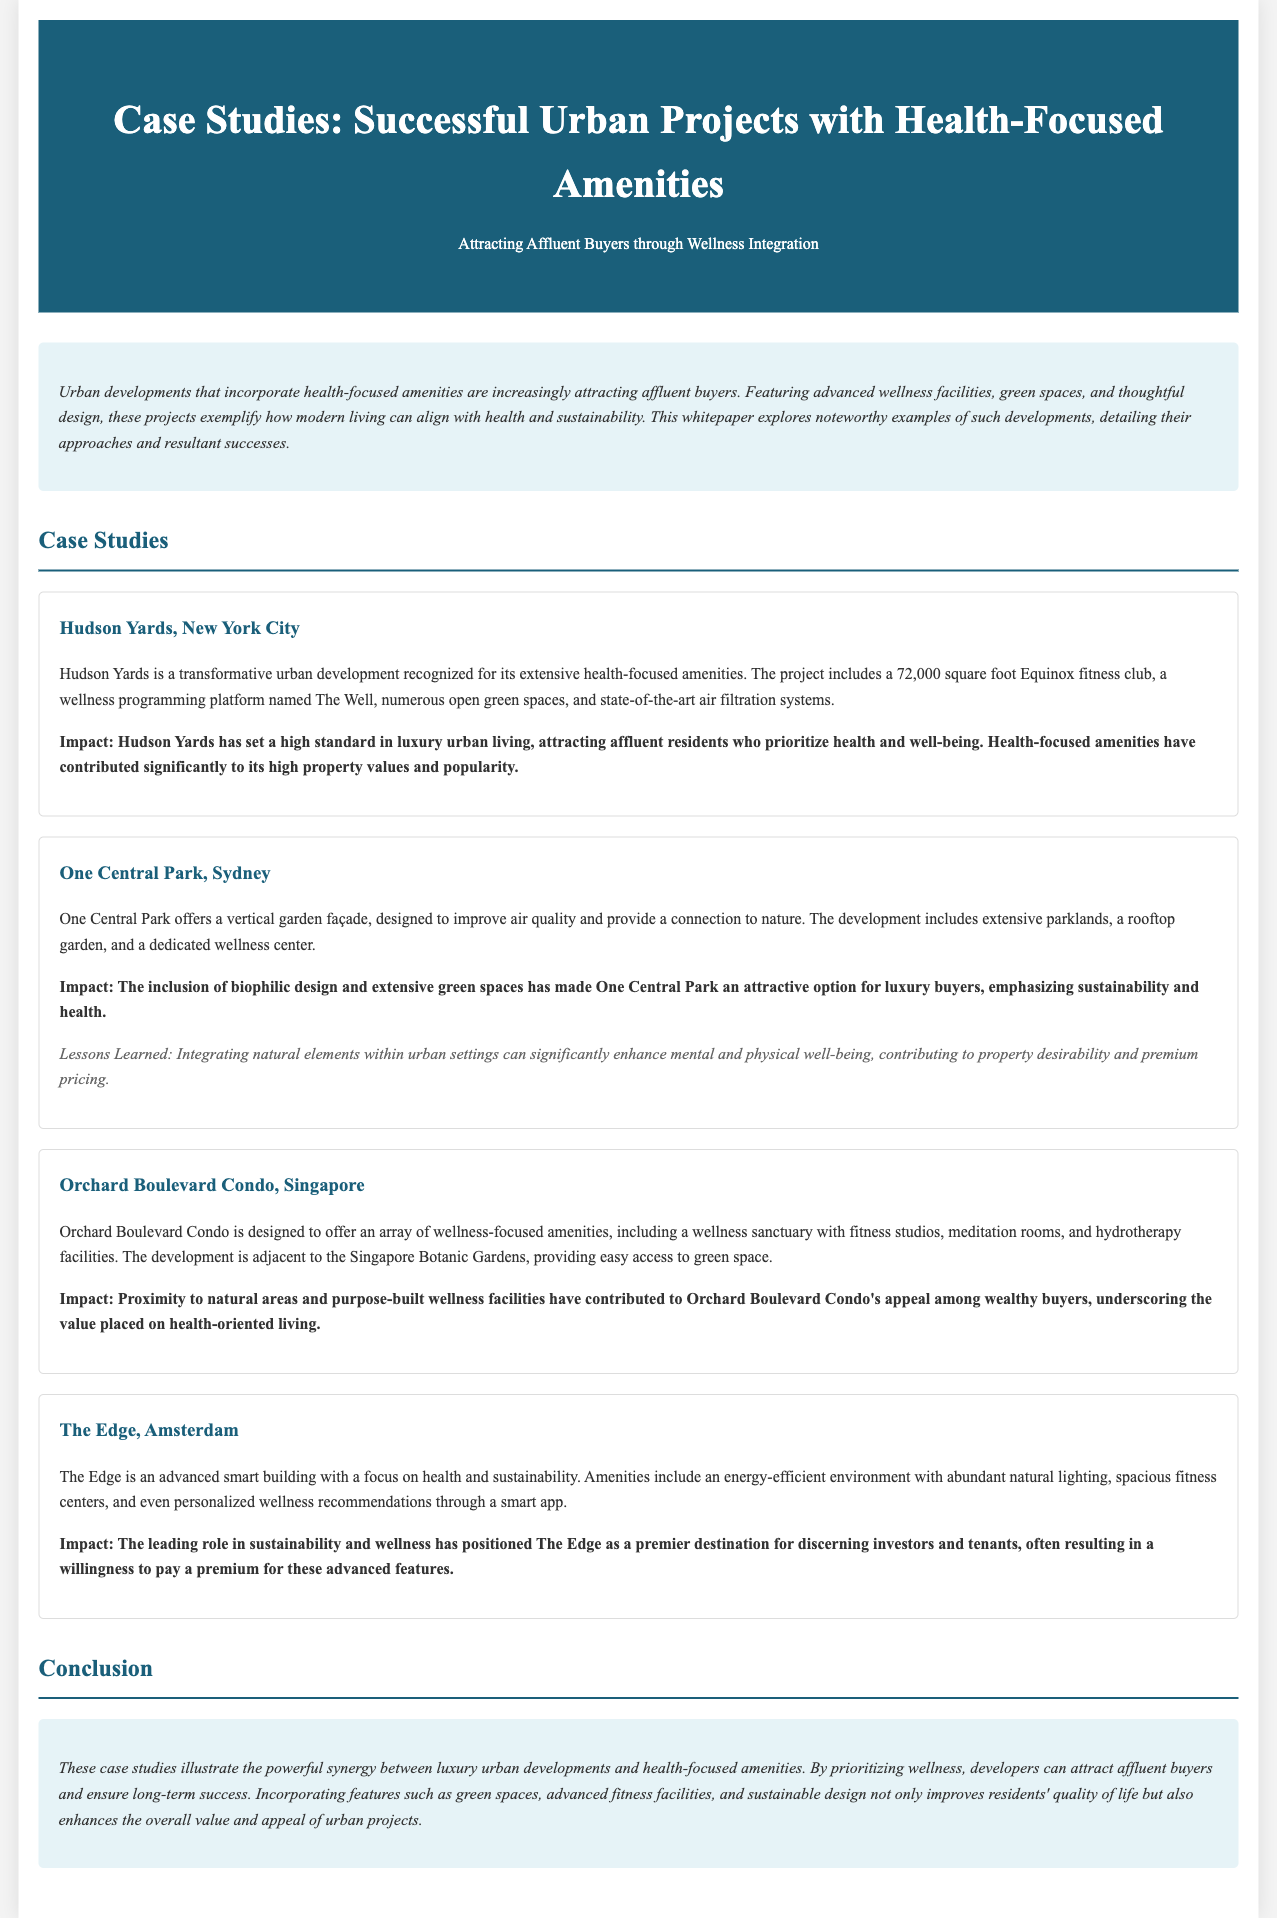What is the total area of the Equinox fitness club at Hudson Yards? The total area of the Equinox fitness club at Hudson Yards is provided as 72,000 square feet in the document.
Answer: 72,000 square feet What type of garden is featured at One Central Park? The type of garden featured at One Central Park is described as a vertical garden façade designed to improve air quality.
Answer: Vertical garden What wellness amenities are offered at Orchard Boulevard Condo? The document mentions that Orchard Boulevard Condo includes fitness studios, meditation rooms, and hydrotherapy facilities as part of its wellness amenities.
Answer: Fitness studios, meditation rooms, hydrotherapy facilities What is the main focus of The Edge in Amsterdam? The main focus of The Edge is highlighted as health and sustainability in the document.
Answer: Health and sustainability How does Hudson Yards impact property values? According to the document, Hudson Yards has contributed significantly to high property values and popularity due to its health-focused amenities.
Answer: High property values What lesson is emphasized in the case study of One Central Park? The lesson emphasized in the One Central Park case study highlights the significance of integrating natural elements within urban settings for enhancing well-being.
Answer: Integrating natural elements What type of app is mentioned in relation to The Edge? The document references a smart app that provides personalized wellness recommendations for The Edge.
Answer: Smart app What feature is listed as part of the amenities in One Central Park? One feature listed as part of the amenities in One Central Park is extensive parklands.
Answer: Extensive parklands What is a key benefit of incorporating health-focused amenities according to the conclusion? The conclusion states that incorporating health-focused amenities improves residents' quality of life, which is a key benefit.
Answer: Improves quality of life 